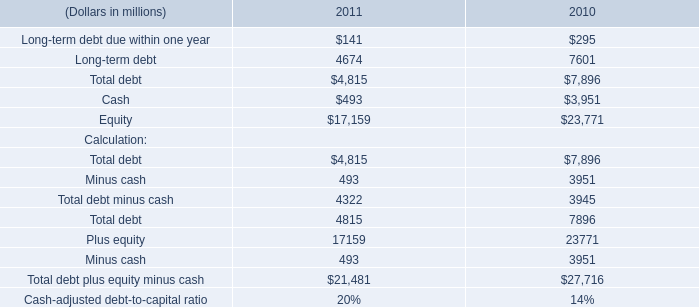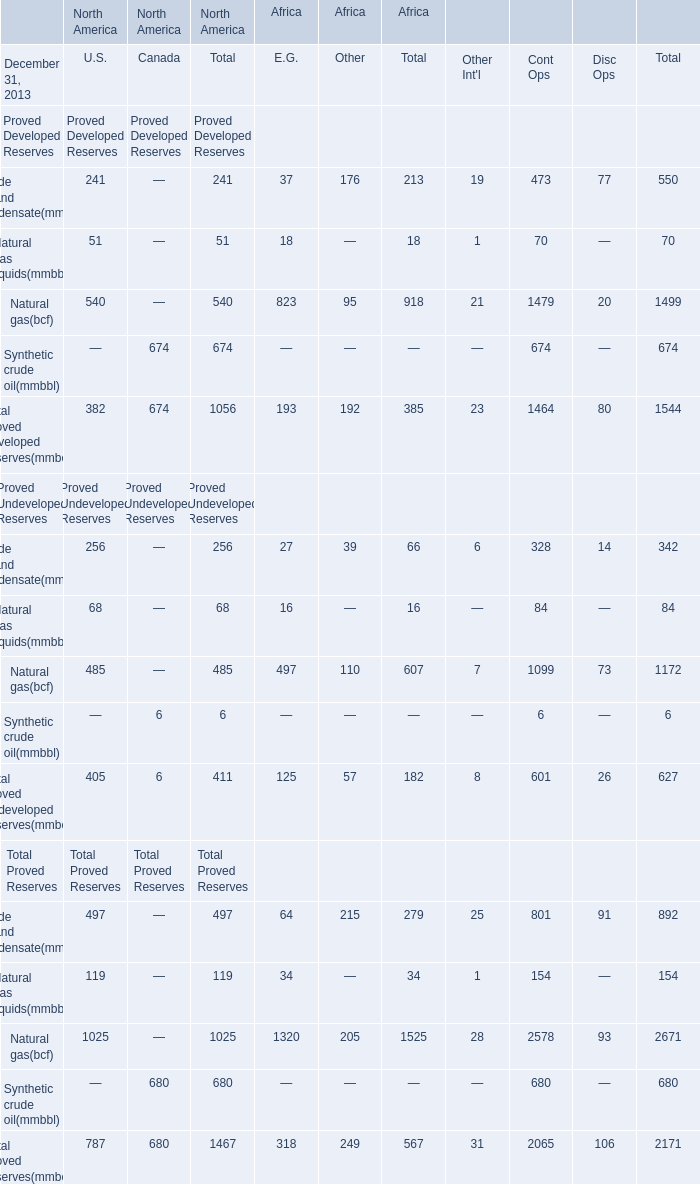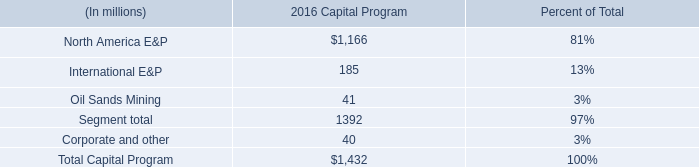What is the sum of Proved U.S. in 2013? 
Computations: (((((((((((241 + 51) + 540) + 382) + 256) + 68) + 485) + 405) + 497) + 119) + 1025) + 787)
Answer: 4856.0. 